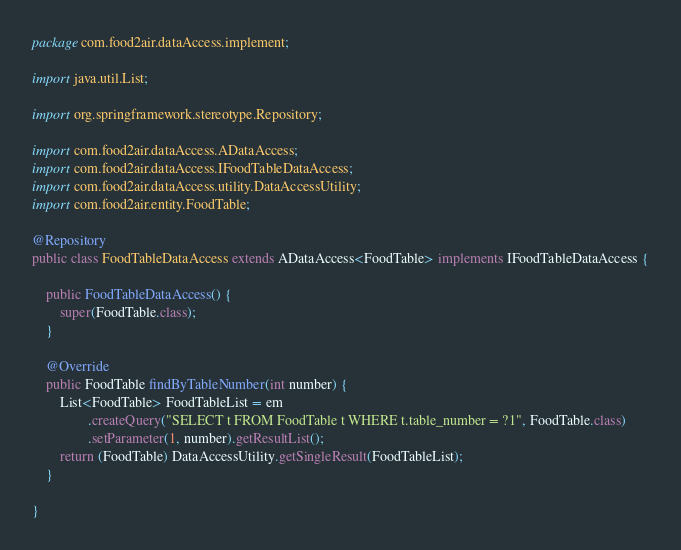<code> <loc_0><loc_0><loc_500><loc_500><_Java_>package com.food2air.dataAccess.implement;

import java.util.List;

import org.springframework.stereotype.Repository;

import com.food2air.dataAccess.ADataAccess;
import com.food2air.dataAccess.IFoodTableDataAccess;
import com.food2air.dataAccess.utility.DataAccessUtility;
import com.food2air.entity.FoodTable;

@Repository
public class FoodTableDataAccess extends ADataAccess<FoodTable> implements IFoodTableDataAccess {

	public FoodTableDataAccess() {
		super(FoodTable.class);
	}

	@Override
	public FoodTable findByTableNumber(int number) {
		List<FoodTable> FoodTableList = em
				.createQuery("SELECT t FROM FoodTable t WHERE t.table_number = ?1", FoodTable.class)
				.setParameter(1, number).getResultList();
		return (FoodTable) DataAccessUtility.getSingleResult(FoodTableList);
	}

}</code> 